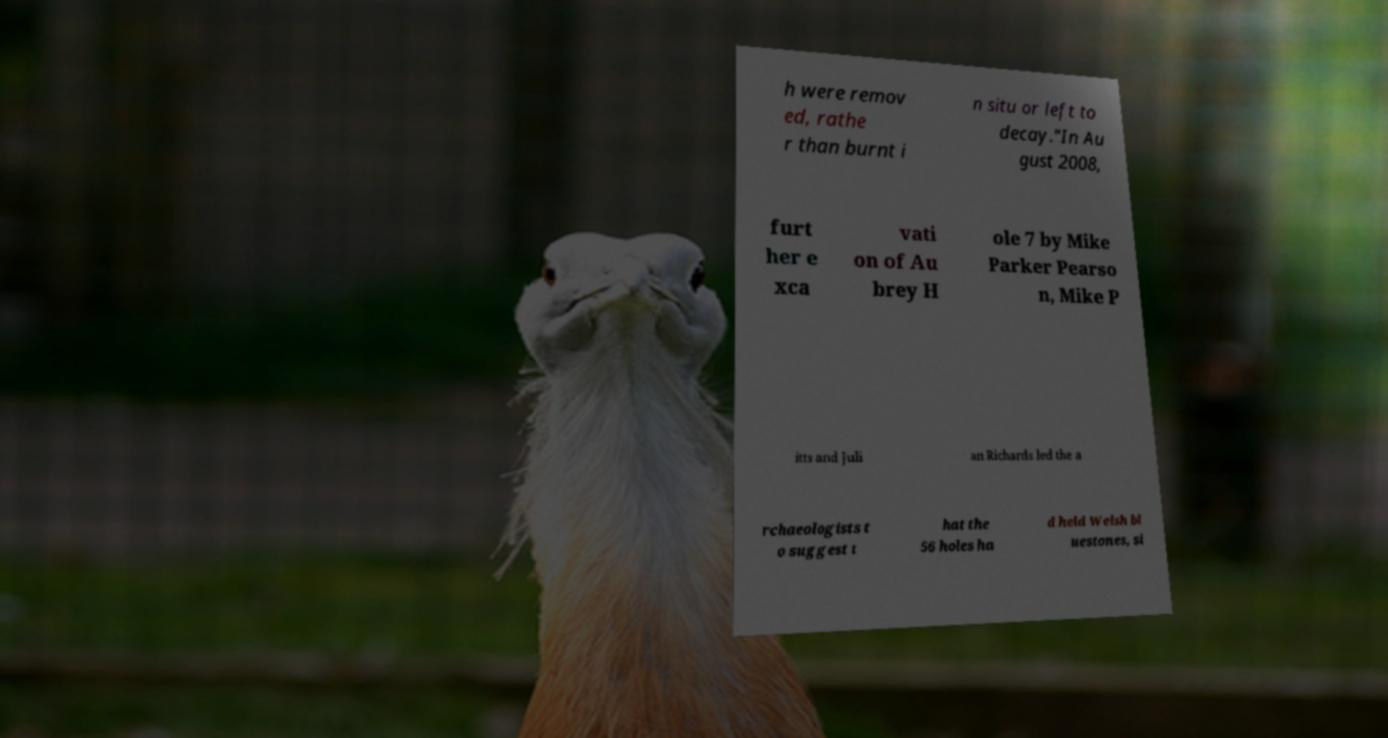I need the written content from this picture converted into text. Can you do that? h were remov ed, rathe r than burnt i n situ or left to decay."In Au gust 2008, furt her e xca vati on of Au brey H ole 7 by Mike Parker Pearso n, Mike P itts and Juli an Richards led the a rchaeologists t o suggest t hat the 56 holes ha d held Welsh bl uestones, si 